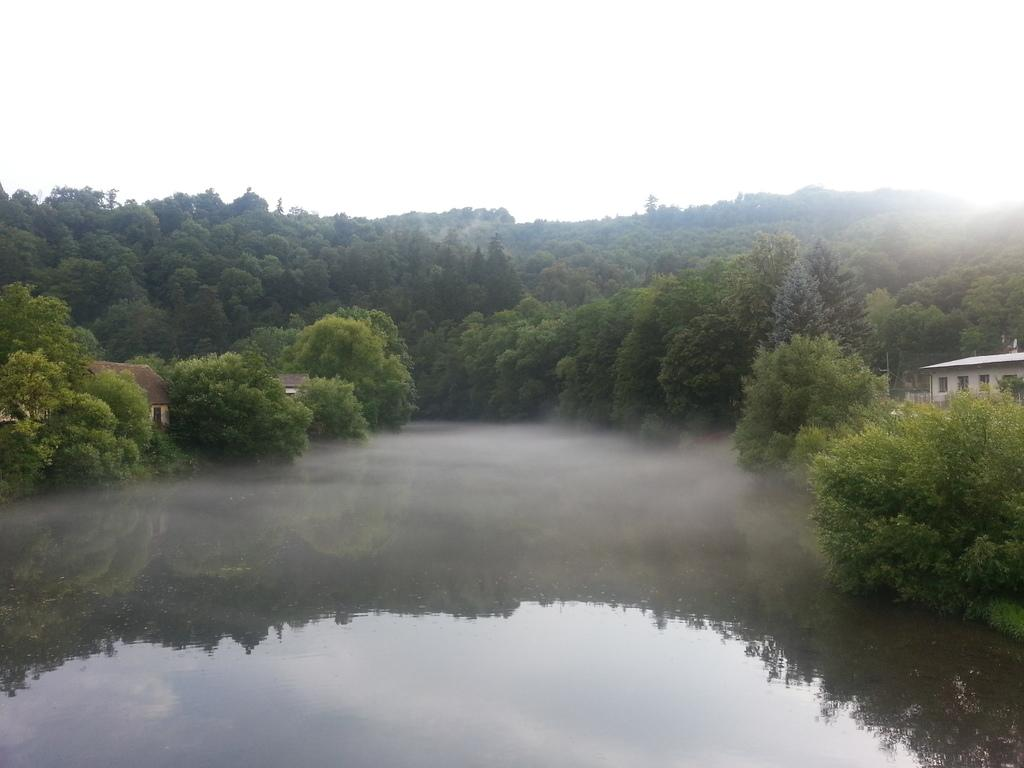What is visible in the image that is not a solid structure? Water is visible in the image. What type of natural vegetation can be seen in the image? There are trees in the image. What type of human-made structures are present in the image? There are houses in the image. What is visible above the houses and trees in the image? The sky is visible in the image. Can you see a man holding a string around his wrist in the image? There is no man or string visible in the image. 